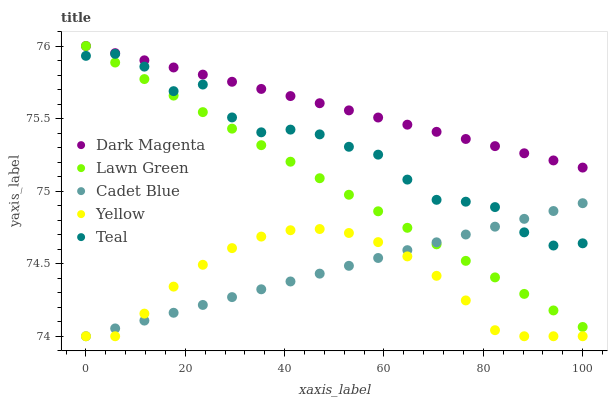Does Yellow have the minimum area under the curve?
Answer yes or no. Yes. Does Dark Magenta have the maximum area under the curve?
Answer yes or no. Yes. Does Lawn Green have the minimum area under the curve?
Answer yes or no. No. Does Lawn Green have the maximum area under the curve?
Answer yes or no. No. Is Dark Magenta the smoothest?
Answer yes or no. Yes. Is Teal the roughest?
Answer yes or no. Yes. Is Lawn Green the smoothest?
Answer yes or no. No. Is Lawn Green the roughest?
Answer yes or no. No. Does Cadet Blue have the lowest value?
Answer yes or no. Yes. Does Lawn Green have the lowest value?
Answer yes or no. No. Does Dark Magenta have the highest value?
Answer yes or no. Yes. Does Cadet Blue have the highest value?
Answer yes or no. No. Is Yellow less than Teal?
Answer yes or no. Yes. Is Dark Magenta greater than Yellow?
Answer yes or no. Yes. Does Lawn Green intersect Dark Magenta?
Answer yes or no. Yes. Is Lawn Green less than Dark Magenta?
Answer yes or no. No. Is Lawn Green greater than Dark Magenta?
Answer yes or no. No. Does Yellow intersect Teal?
Answer yes or no. No. 